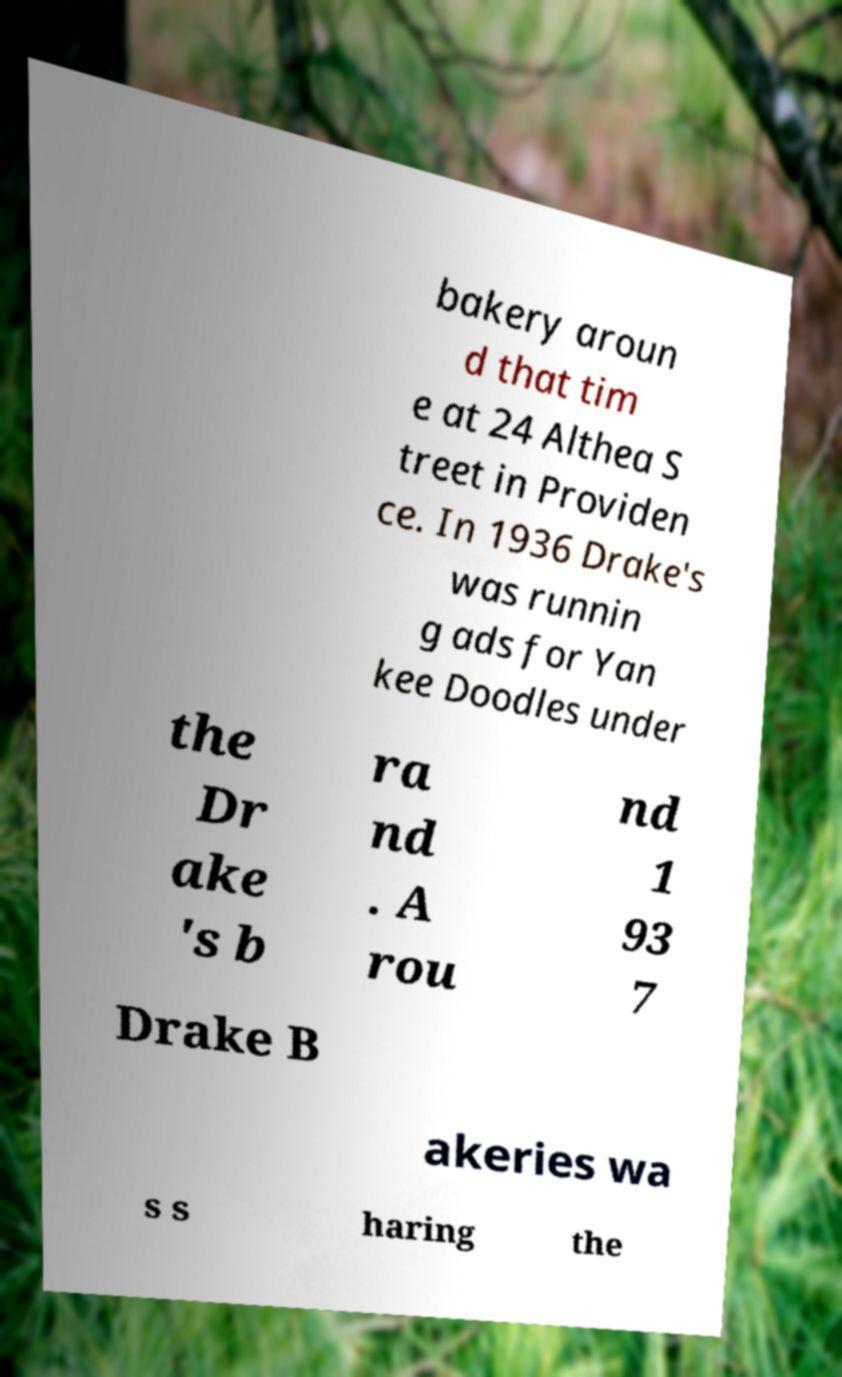I need the written content from this picture converted into text. Can you do that? bakery aroun d that tim e at 24 Althea S treet in Providen ce. In 1936 Drake's was runnin g ads for Yan kee Doodles under the Dr ake 's b ra nd . A rou nd 1 93 7 Drake B akeries wa s s haring the 